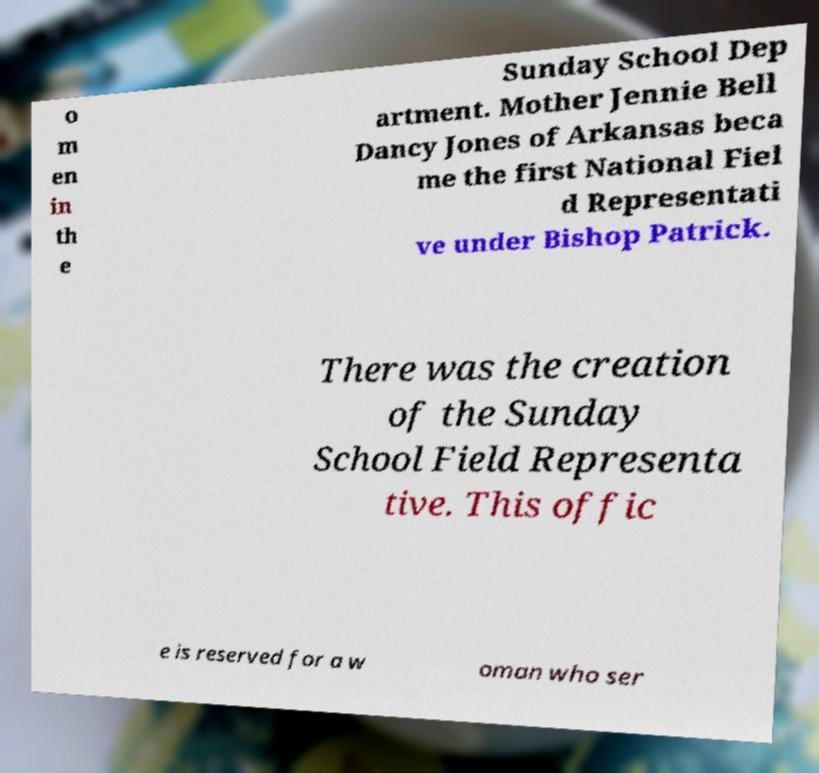There's text embedded in this image that I need extracted. Can you transcribe it verbatim? o m en in th e Sunday School Dep artment. Mother Jennie Bell Dancy Jones of Arkansas beca me the first National Fiel d Representati ve under Bishop Patrick. There was the creation of the Sunday School Field Representa tive. This offic e is reserved for a w oman who ser 